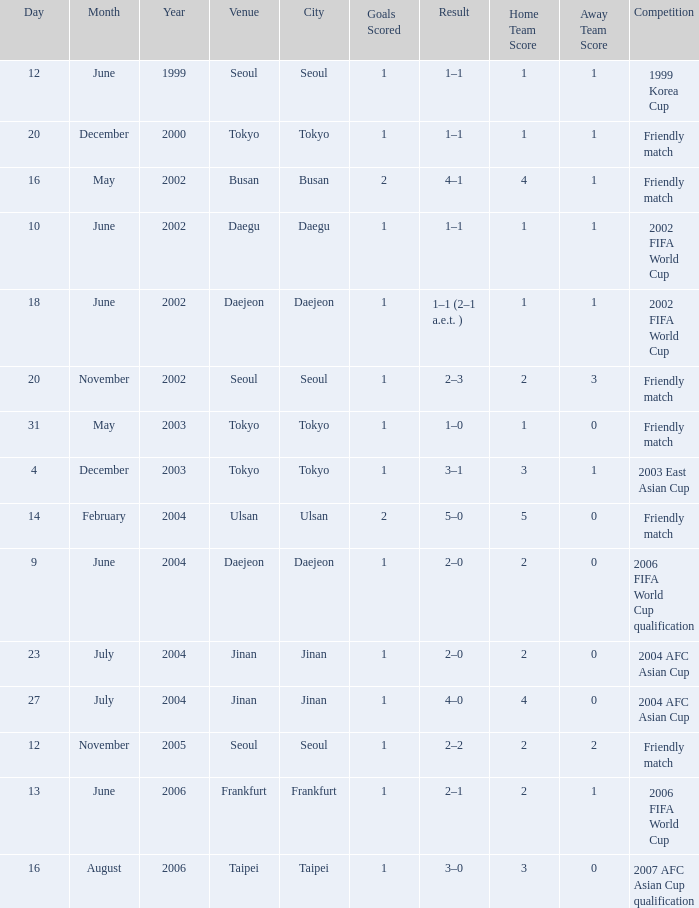What was the score of the game played on 16 August 2006? 1 goal. 